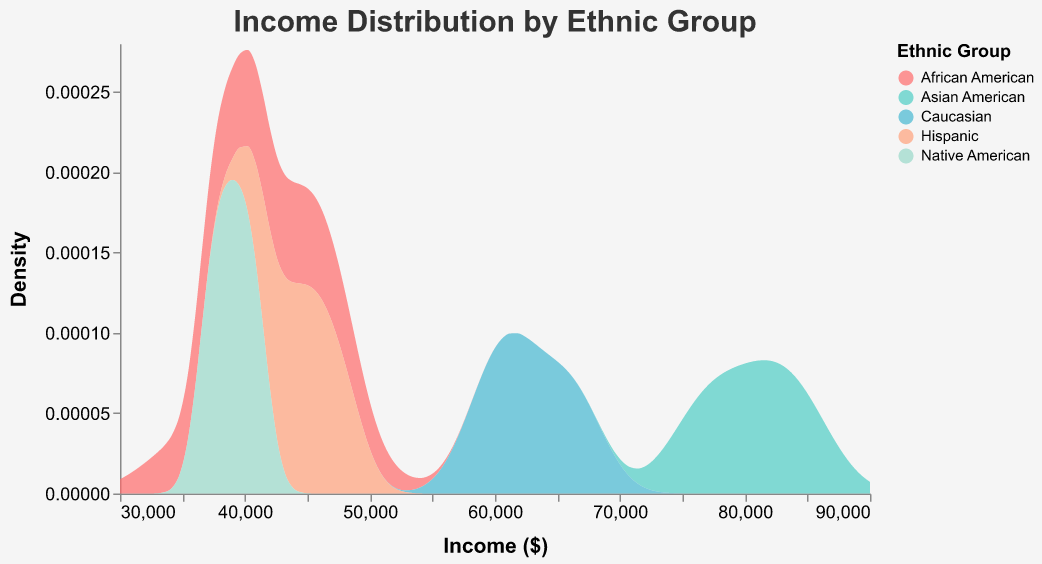What is the title of the plot? The title is located at the top of the plot and is designed to provide a concise summary of the figure's contents. In this case, it is clearly presented as "Income Distribution by Ethnic Group".
Answer: Income Distribution by Ethnic Group Which ethnic group has the highest median income? By observing the density of the income distributions, we note that the peak for Asian Americans is located further to the right compared to other groups. This indicates a higher median income for this group.
Answer: Asian American What is the range of income values considered in the plot? The x-axis represents the range of income values. According to the x-axis labels, the range starts at $30,000 and extends to $90,000.
Answer: $30,000 to $90,000 Which ethnic group shows the sharpest peak in their income distribution? The sharpness of the peak can be inferred from the height and narrowness of the density curves. For this plot, Asian Americans exhibit the sharpest peak, indicating a more concentrated distribution of incomes around their median value.
Answer: Asian American What color represents the income distribution for Native Americans? Each ethnic group is represented by a distinct color within the density plot. The legend indicates that Native Americans are represented by the light green color.
Answer: Light green Between which two ethnic groups is there the largest disparity in median income? To determine this, compare the positions of the peaks of the distributions. Asian Americans and African Americans show the greatest disparity, with the Asian American income distribution peaking much higher than the African American group's distribution.
Answer: Asian American and African American How many ethnic groups are represented in the plot? To find out the number of ethnic groups, examine the legend or count the individual distributions in the plot. There are five distinct groups: African American, Asian American, Caucasian, Hispanic, and Native American.
Answer: Five Which ethnic group's income distribution is most spread out? Distribution spread can be judged by the width of the area under the density curve. Caucasians have a relatively wide distribution compared to the other groups, indicating a larger spread in income levels.
Answer: Caucasian What feature of the plot makes it easy to identify the densities for different ethnic groups? The distinction among ethnic groups in terms of income densities is facilitated by the use of different colors for each group, as shown in the legend.
Answer: Use of different colors Is there any group with a significant overlap in income distribution with another group? By examining the density curves, we observe that the income distributions for African Americans and Hispanics have overlapping regions, indicating similar income ranges for these groups.
Answer: Yes, African American and Hispanic 